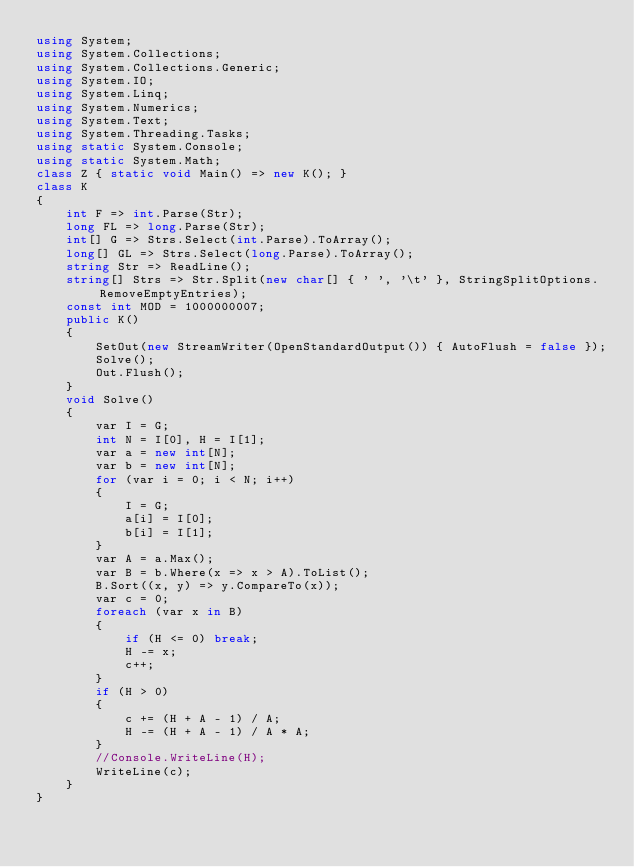<code> <loc_0><loc_0><loc_500><loc_500><_C#_>using System;
using System.Collections;
using System.Collections.Generic;
using System.IO;
using System.Linq;
using System.Numerics;
using System.Text;
using System.Threading.Tasks;
using static System.Console;
using static System.Math;
class Z { static void Main() => new K(); }
class K
{
	int F => int.Parse(Str);
	long FL => long.Parse(Str);
	int[] G => Strs.Select(int.Parse).ToArray();
	long[] GL => Strs.Select(long.Parse).ToArray();
	string Str => ReadLine();
	string[] Strs => Str.Split(new char[] { ' ', '\t' }, StringSplitOptions.RemoveEmptyEntries);
	const int MOD = 1000000007;
	public K()
	{
		SetOut(new StreamWriter(OpenStandardOutput()) { AutoFlush = false });
		Solve();
		Out.Flush();
	}
	void Solve()
	{
		var I = G;
		int N = I[0], H = I[1];
		var a = new int[N];
		var b = new int[N];
		for (var i = 0; i < N; i++)
		{
			I = G;
			a[i] = I[0];
			b[i] = I[1];
		}
		var A = a.Max();
		var B = b.Where(x => x > A).ToList();
		B.Sort((x, y) => y.CompareTo(x));
		var c = 0;
		foreach (var x in B)
		{
			if (H <= 0) break;
			H -= x;
			c++;
		}
		if (H > 0)
		{
			c += (H + A - 1) / A;
			H -= (H + A - 1) / A * A;
		}
		//Console.WriteLine(H);
		WriteLine(c);
	}
}
</code> 